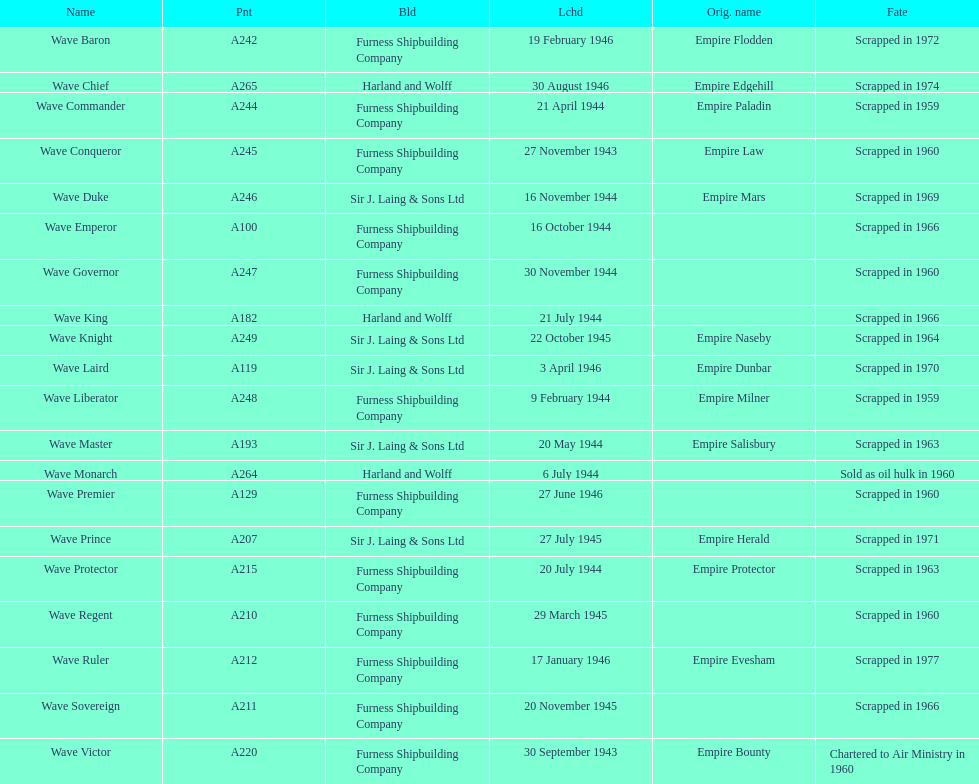Name a builder with "and" in the name. Harland and Wolff. 